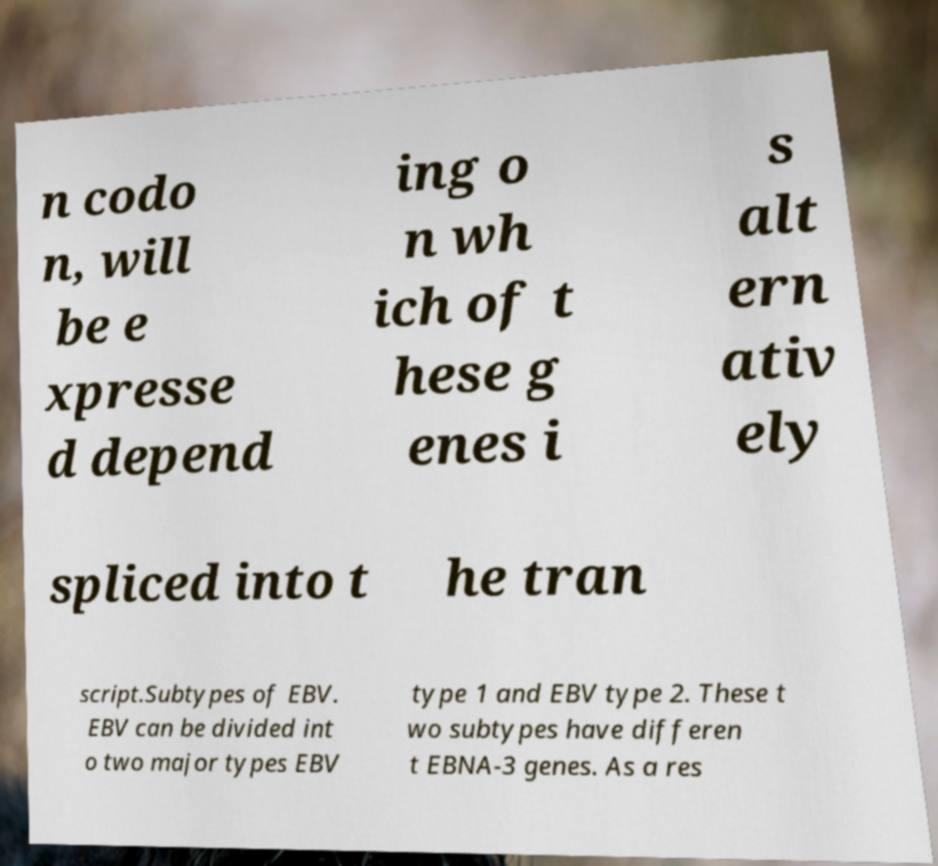Please identify and transcribe the text found in this image. n codo n, will be e xpresse d depend ing o n wh ich of t hese g enes i s alt ern ativ ely spliced into t he tran script.Subtypes of EBV. EBV can be divided int o two major types EBV type 1 and EBV type 2. These t wo subtypes have differen t EBNA-3 genes. As a res 